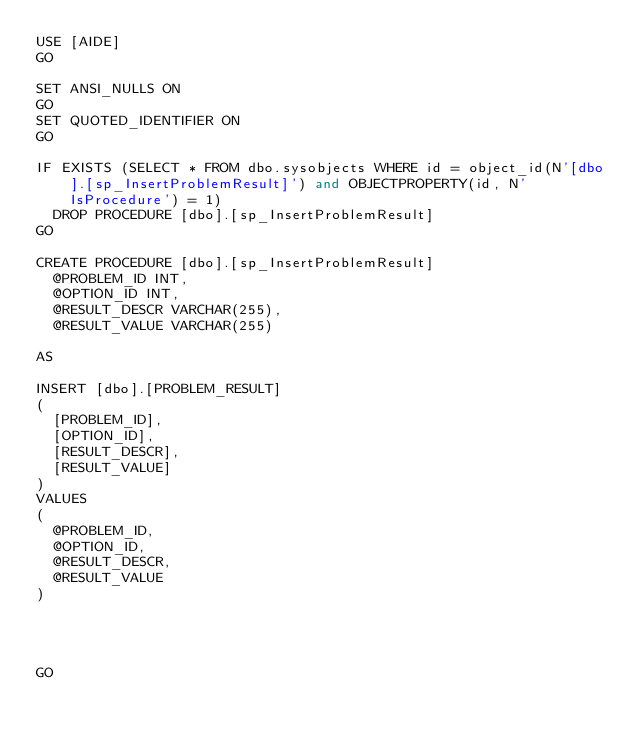<code> <loc_0><loc_0><loc_500><loc_500><_SQL_>USE [AIDE]
GO

SET ANSI_NULLS ON
GO
SET QUOTED_IDENTIFIER ON
GO

IF EXISTS (SELECT * FROM dbo.sysobjects WHERE id = object_id(N'[dbo].[sp_InsertProblemResult]') and OBJECTPROPERTY(id, N'IsProcedure') = 1)
	DROP PROCEDURE [dbo].[sp_InsertProblemResult]
GO

CREATE PROCEDURE [dbo].[sp_InsertProblemResult]
	@PROBLEM_ID INT,
	@OPTION_ID INT,
	@RESULT_DESCR VARCHAR(255),
	@RESULT_VALUE VARCHAR(255) 

AS

INSERT [dbo].[PROBLEM_RESULT]
(
	[PROBLEM_ID],
	[OPTION_ID],
	[RESULT_DESCR],
	[RESULT_VALUE]
)
VALUES
(
	@PROBLEM_ID,
	@OPTION_ID,
	@RESULT_DESCR,
	@RESULT_VALUE
)




GO
</code> 